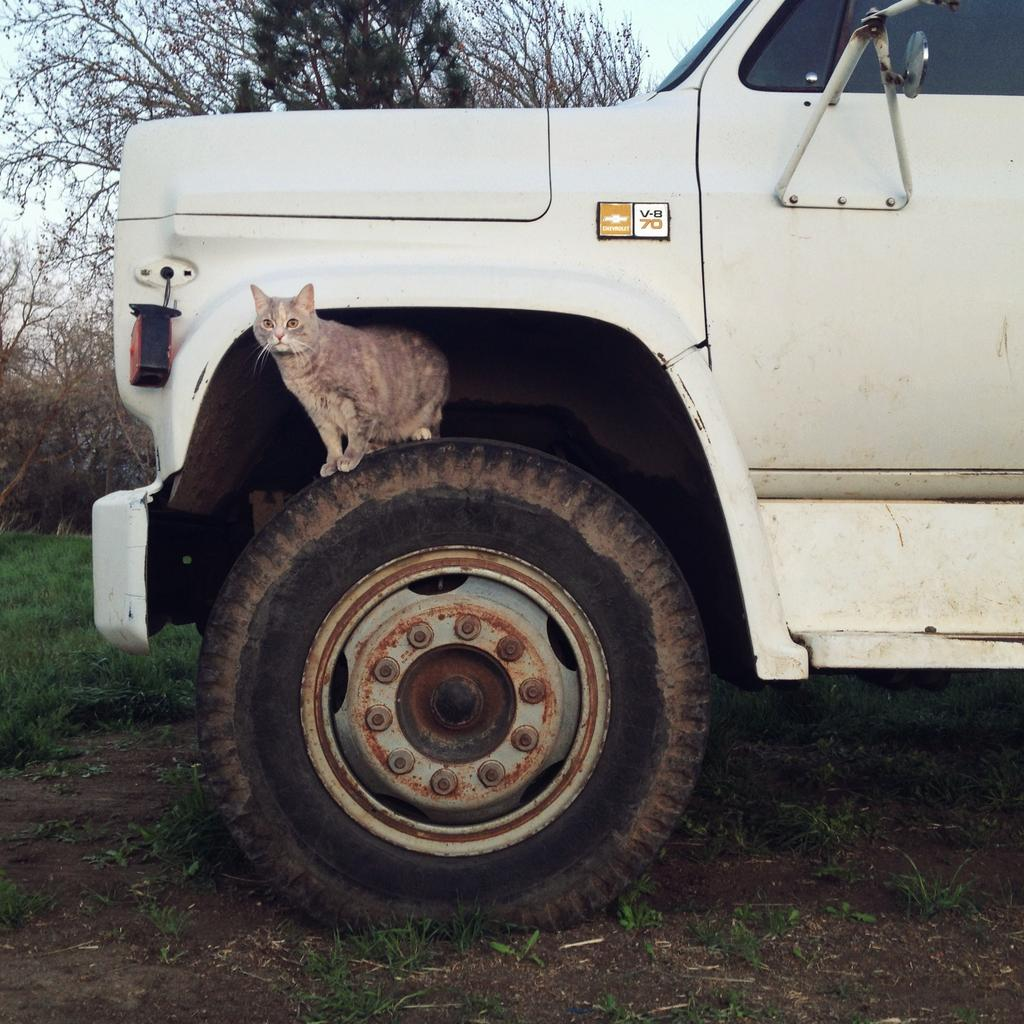What is the main subject in the image? There is a vehicle in the image. Can you describe the cat's location in relation to the vehicle? A cat is present on the tire of the vehicle. What can be seen in the background of the image? There are trees and the sky visible in the background of the image. What type of terrain is at the bottom of the image? There is grass at the bottom of the image. How many cushions are placed on the tin in the image? There is no tin or cushions present in the image. 